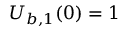Convert formula to latex. <formula><loc_0><loc_0><loc_500><loc_500>U _ { b , 1 } ( 0 ) = 1</formula> 